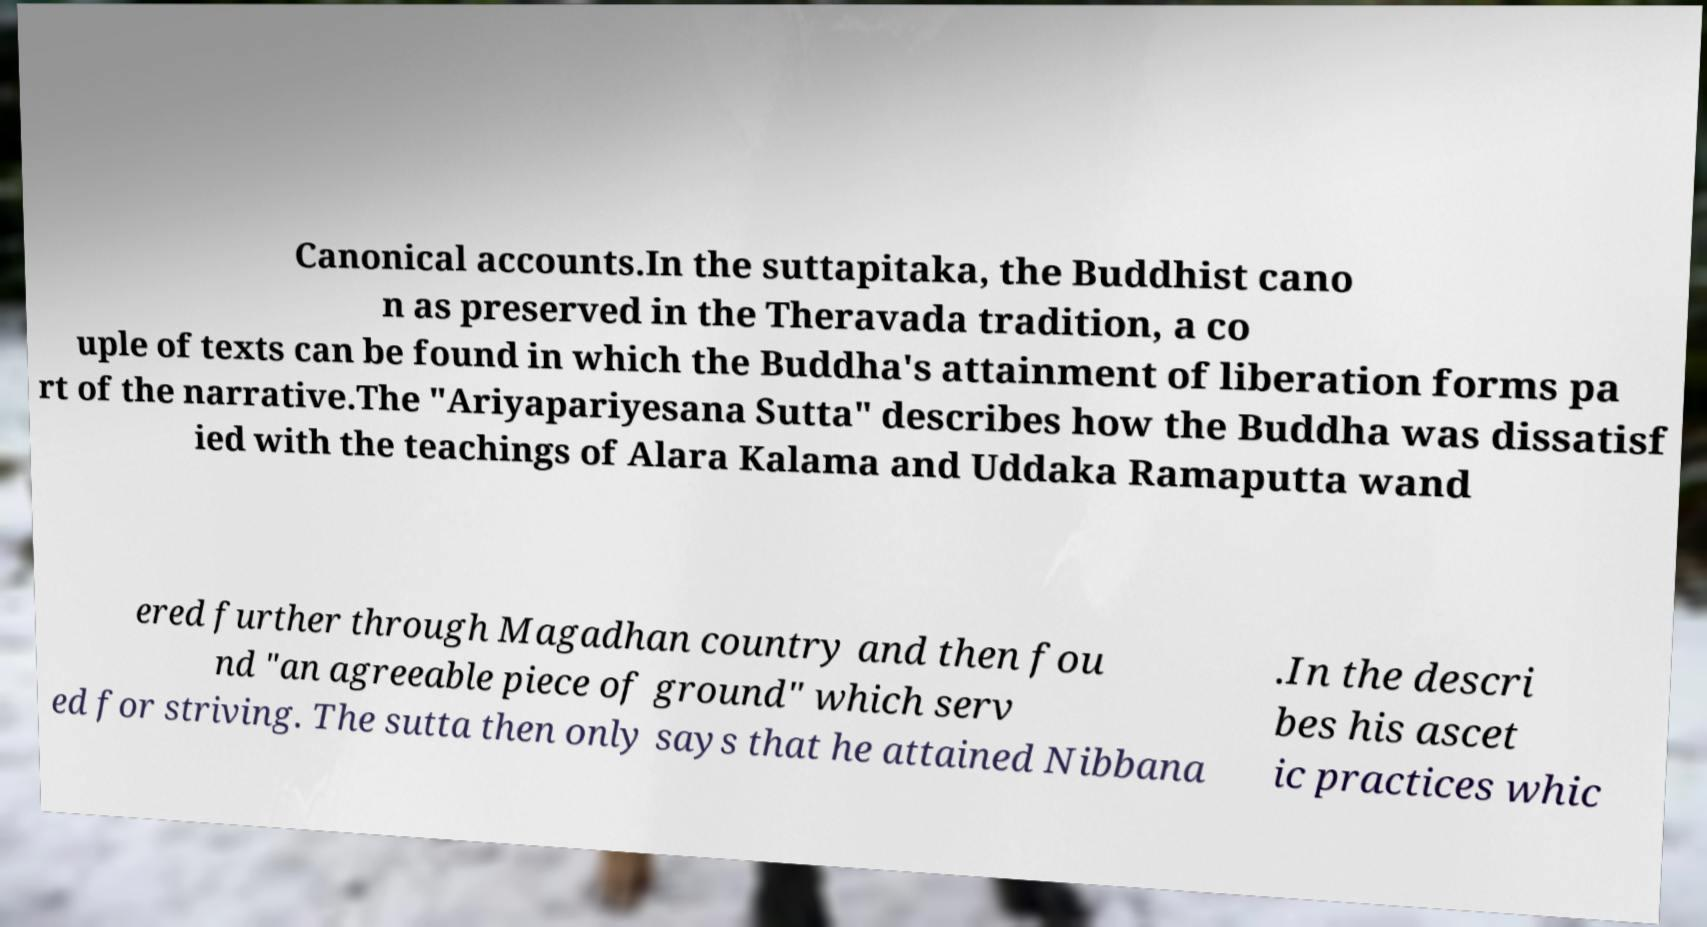Can you accurately transcribe the text from the provided image for me? Canonical accounts.In the suttapitaka, the Buddhist cano n as preserved in the Theravada tradition, a co uple of texts can be found in which the Buddha's attainment of liberation forms pa rt of the narrative.The "Ariyapariyesana Sutta" describes how the Buddha was dissatisf ied with the teachings of Alara Kalama and Uddaka Ramaputta wand ered further through Magadhan country and then fou nd "an agreeable piece of ground" which serv ed for striving. The sutta then only says that he attained Nibbana .In the descri bes his ascet ic practices whic 